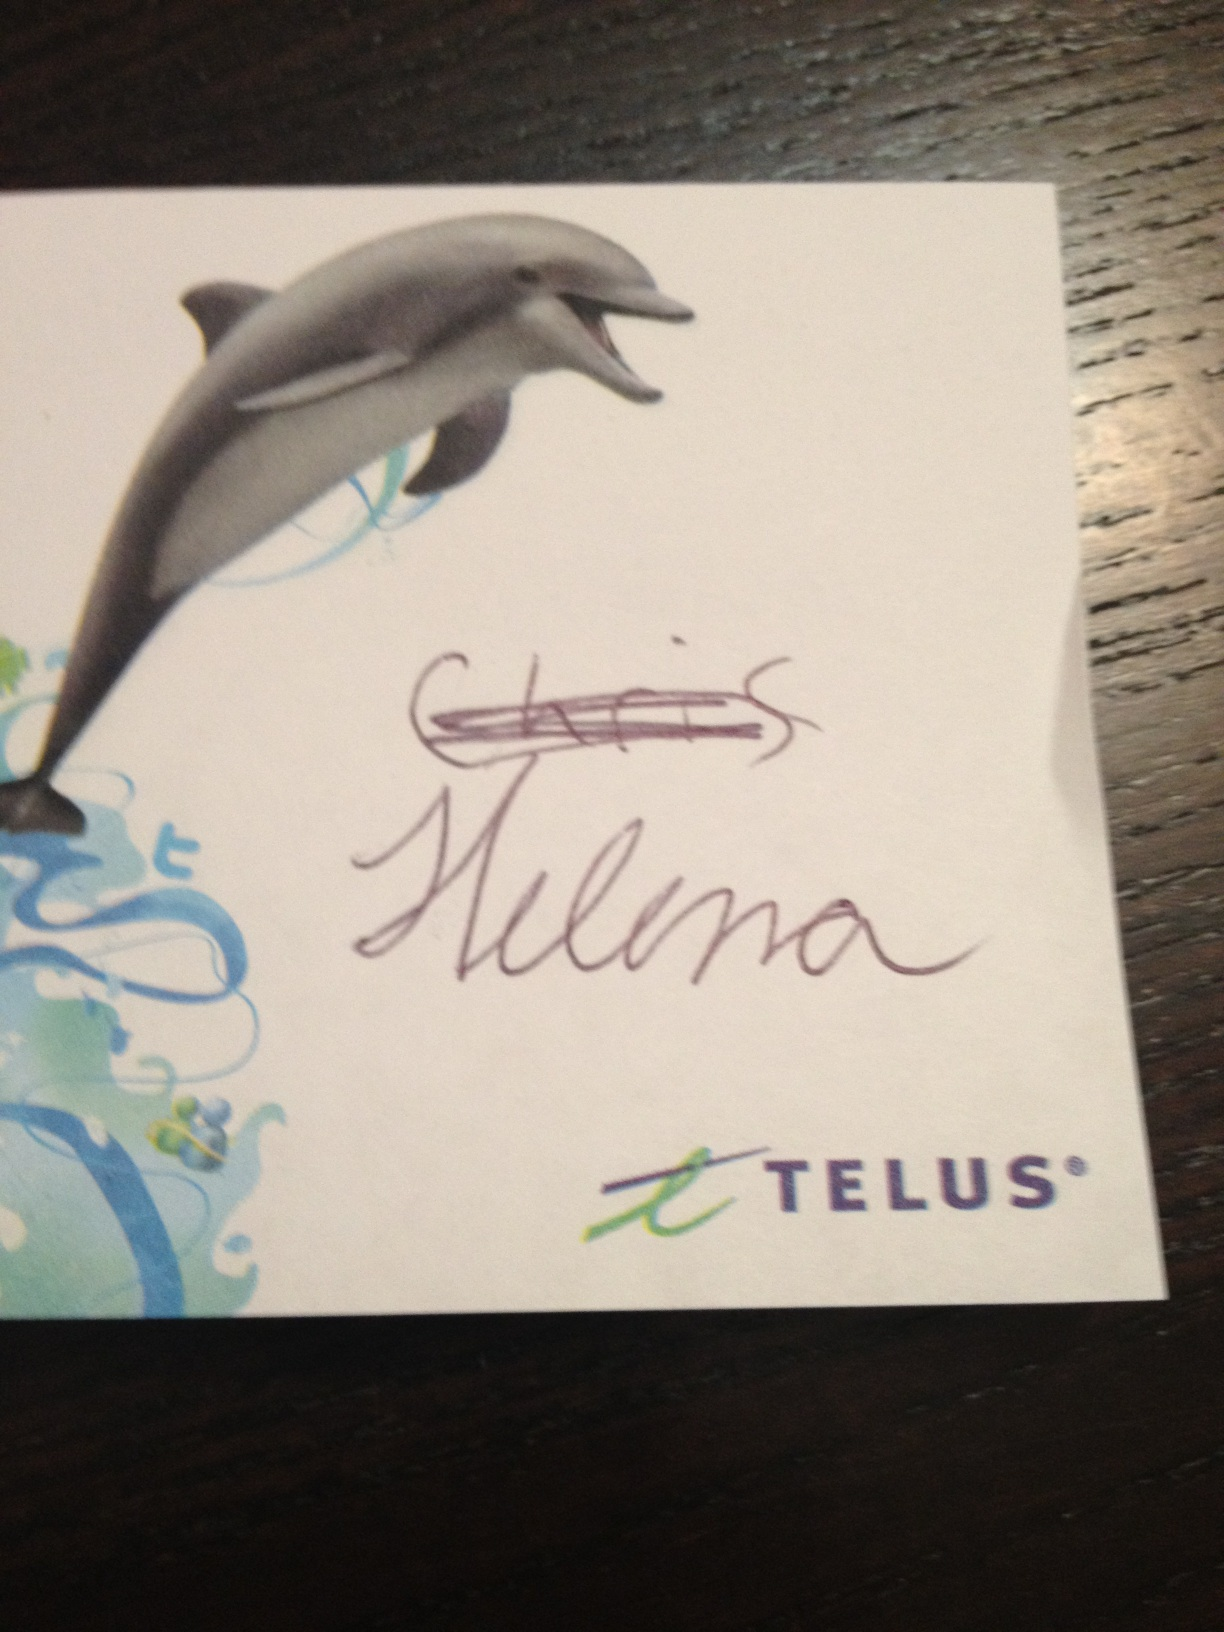Can you tell me more about the company featured in this image? Telus is a Canadian telecommunications company widely recognized in Canada. They provide a range of services including internet access, voice, entertainment, and healthcare technology solutions. Telus is also known for its strong corporate social responsibility efforts, particularly in environmental sustainability and community projects. 